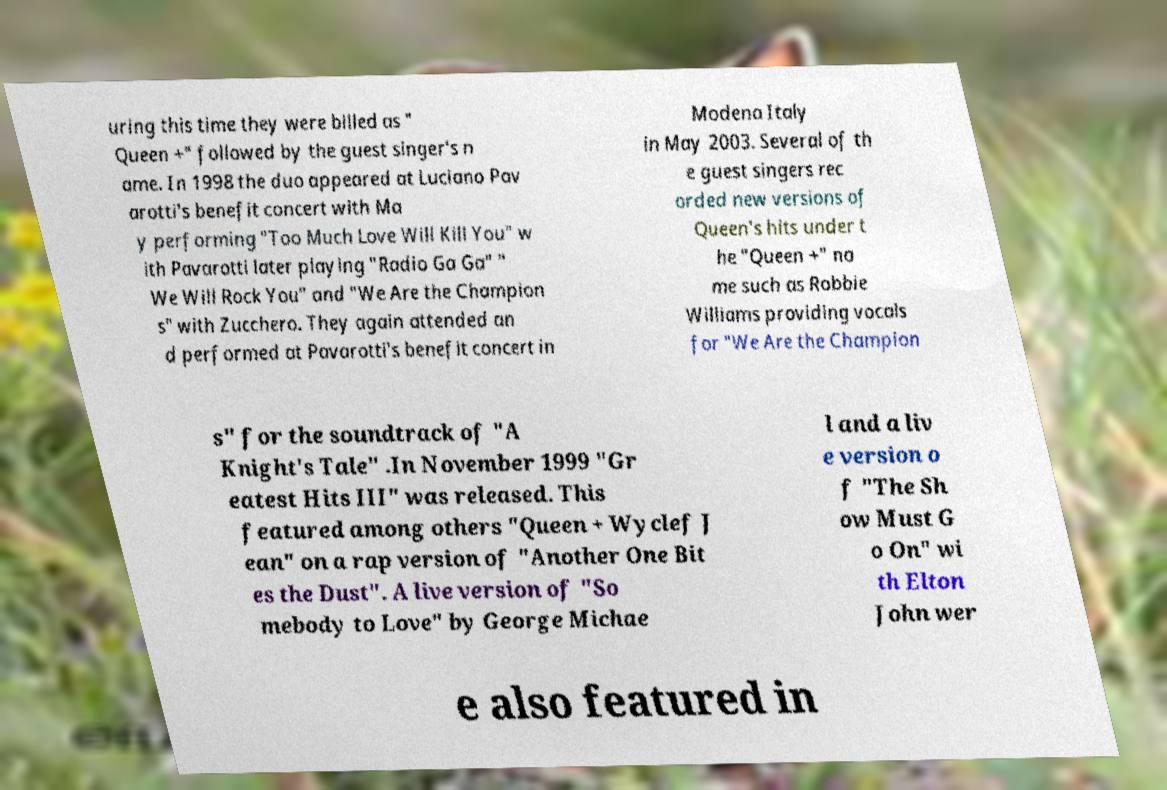Could you extract and type out the text from this image? uring this time they were billed as " Queen +" followed by the guest singer's n ame. In 1998 the duo appeared at Luciano Pav arotti's benefit concert with Ma y performing "Too Much Love Will Kill You" w ith Pavarotti later playing "Radio Ga Ga" " We Will Rock You" and "We Are the Champion s" with Zucchero. They again attended an d performed at Pavarotti's benefit concert in Modena Italy in May 2003. Several of th e guest singers rec orded new versions of Queen's hits under t he "Queen +" na me such as Robbie Williams providing vocals for "We Are the Champion s" for the soundtrack of "A Knight's Tale" .In November 1999 "Gr eatest Hits III" was released. This featured among others "Queen + Wyclef J ean" on a rap version of "Another One Bit es the Dust". A live version of "So mebody to Love" by George Michae l and a liv e version o f "The Sh ow Must G o On" wi th Elton John wer e also featured in 